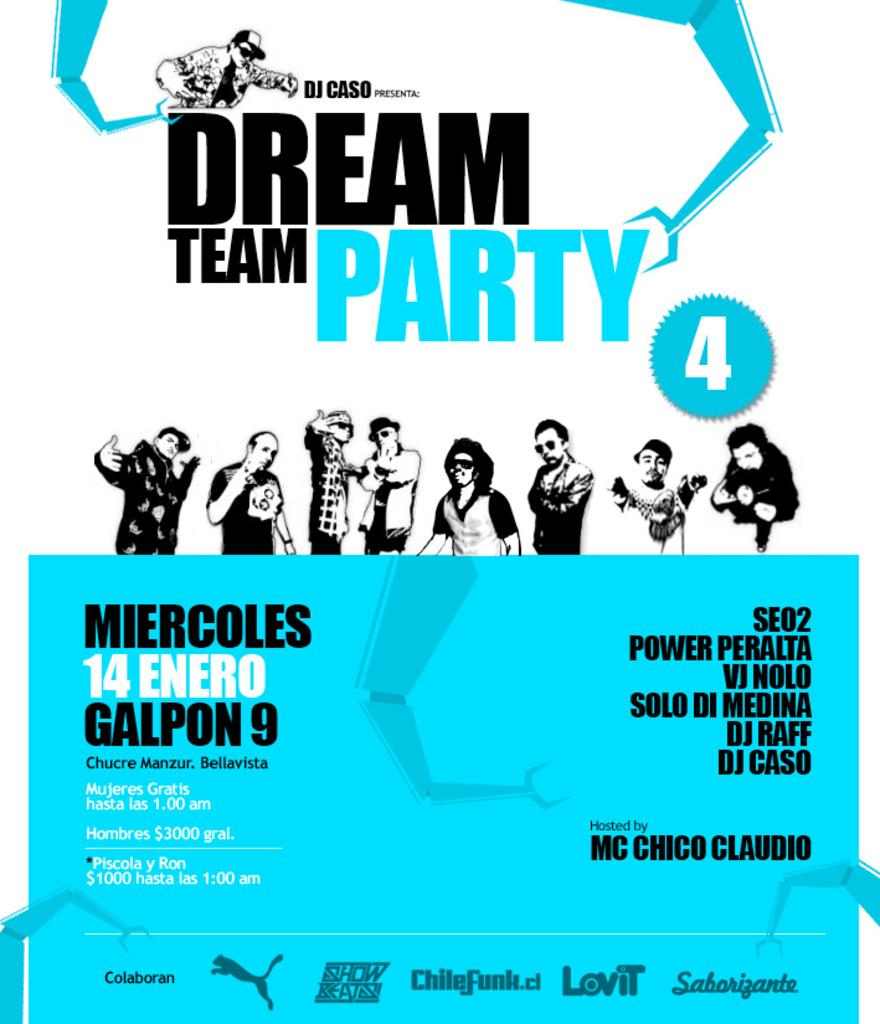What is the main object in the image? There is a pamphlet in the image. What information is displayed on the pamphlet? The pamphlet has the text "Dream Team Party" on it. Are there any visual elements on the pamphlet? Yes, there are images of people on the pamphlet. Can you see any pleasure in the image? The image does not depict any pleasure; it features a pamphlet with text and images. Is there a drawer visible in the image? There is no drawer present in the image. 